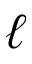<formula> <loc_0><loc_0><loc_500><loc_500>\ell</formula> 